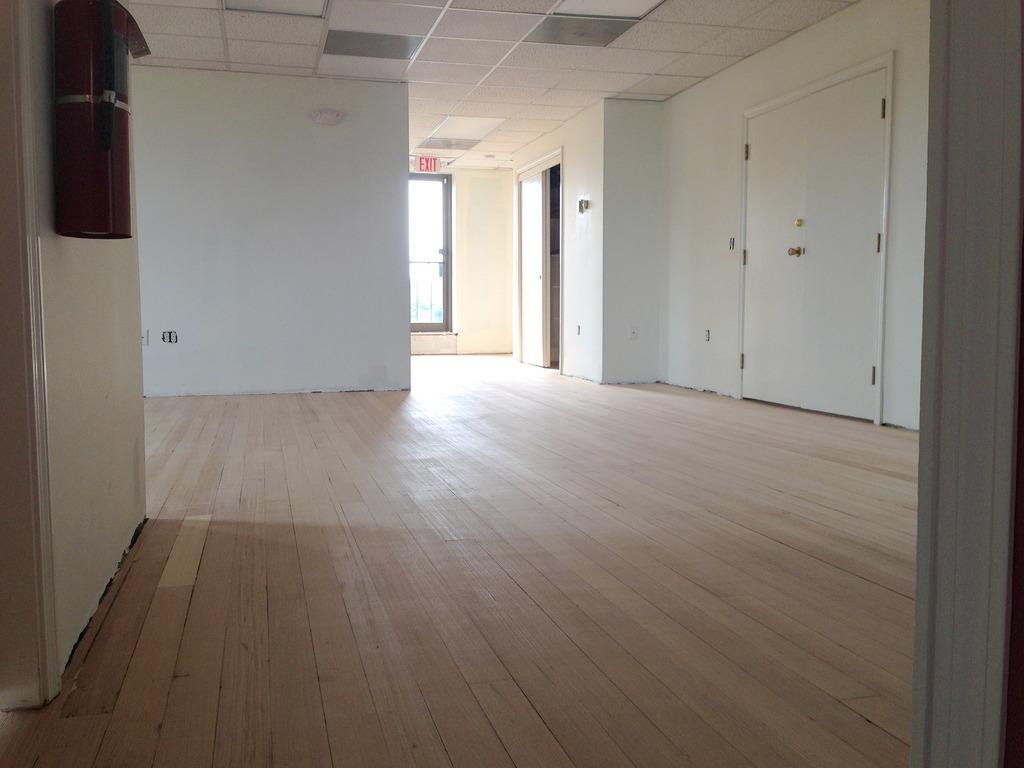What type of setting is depicted in the image? The image is an inside view of a house. What architectural features can be seen in the image? There are doors and a window visible in the image. What other object is present in the image? There is a board in the image. Can you tell me how many pancakes are stacked on the grandfather's coil in the image? There is no grandfather or coil present in the image, and therefore no pancakes can be observed. 